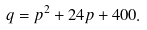Convert formula to latex. <formula><loc_0><loc_0><loc_500><loc_500>q = p ^ { 2 } + 2 4 p + 4 0 0 .</formula> 